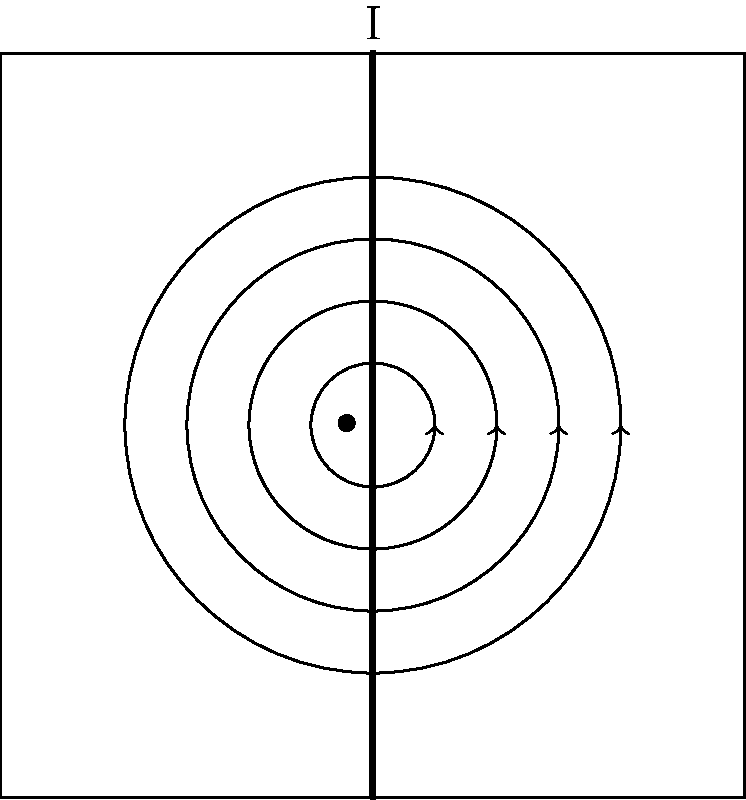A straight wire carries a current I flowing upwards, as shown in the figure. Which statement correctly describes the direction of the magnetic field lines around the wire? To determine the direction of the magnetic field lines around a straight current-carrying wire, we can use the right-hand rule. Here's a step-by-step explanation:

1. Identify the direction of the current: In this case, the current I is flowing upwards.

2. Apply the right-hand rule:
   a. Imagine grasping the wire with your right hand.
   b. Position your thumb to point in the direction of the current (upwards).
   c. Your curled fingers will then indicate the direction of the magnetic field lines.

3. Analyze the result: When applying the right-hand rule, you'll find that your fingers curl around the wire in a counterclockwise direction when looking down on the wire from above.

4. Interpret the diagram: The circular arrows in the figure represent the magnetic field lines. They are drawn as concentric circles around the wire, with arrowheads indicating a counterclockwise direction.

5. Conclusion: The magnetic field lines form concentric circles around the wire and circulate in a counterclockwise direction when viewed from above.

This pattern is consistent with Ampère's law, which relates the magnetic field around a closed loop to the electric current passing through the loop. The strength of the magnetic field decreases with distance from the wire, which is why the circles are drawn at different radii.
Answer: Counterclockwise when viewed from above 